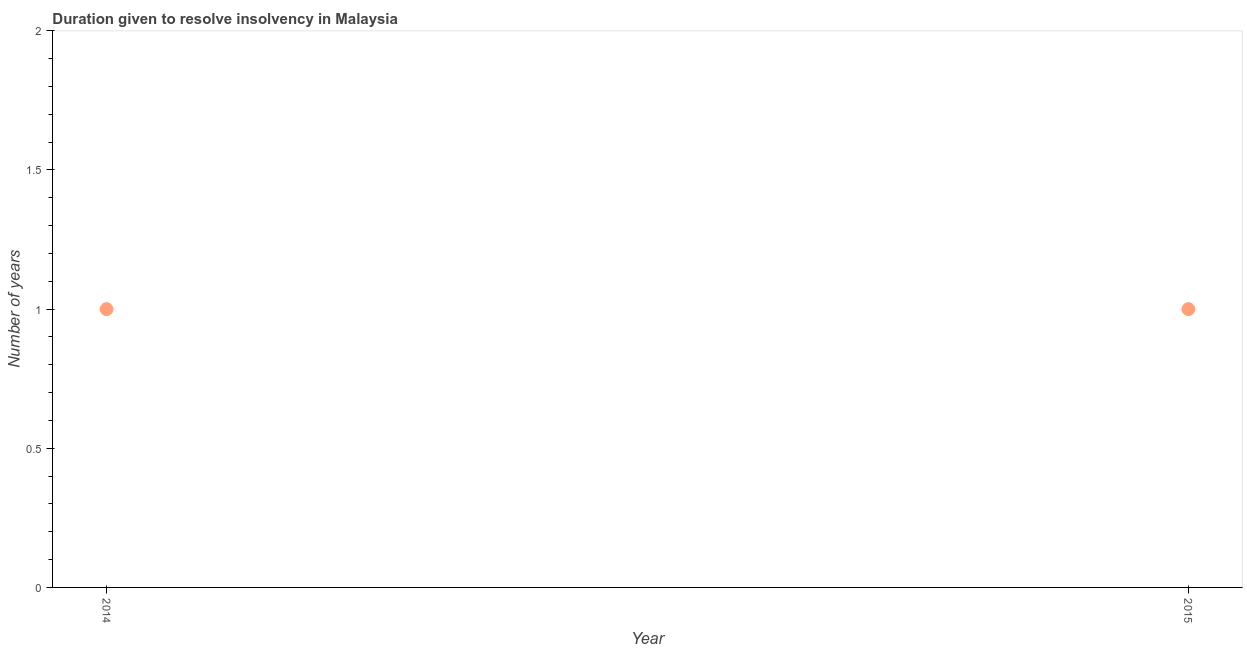What is the number of years to resolve insolvency in 2015?
Ensure brevity in your answer.  1. Across all years, what is the maximum number of years to resolve insolvency?
Give a very brief answer. 1. Across all years, what is the minimum number of years to resolve insolvency?
Your response must be concise. 1. What is the sum of the number of years to resolve insolvency?
Provide a succinct answer. 2. What is the difference between the number of years to resolve insolvency in 2014 and 2015?
Your response must be concise. 0. What is the average number of years to resolve insolvency per year?
Keep it short and to the point. 1. What is the median number of years to resolve insolvency?
Offer a terse response. 1. Do a majority of the years between 2015 and 2014 (inclusive) have number of years to resolve insolvency greater than 1.7 ?
Your answer should be compact. No. What is the ratio of the number of years to resolve insolvency in 2014 to that in 2015?
Your answer should be very brief. 1. Does the number of years to resolve insolvency monotonically increase over the years?
Ensure brevity in your answer.  No. Does the graph contain any zero values?
Provide a short and direct response. No. What is the title of the graph?
Offer a terse response. Duration given to resolve insolvency in Malaysia. What is the label or title of the X-axis?
Your answer should be very brief. Year. What is the label or title of the Y-axis?
Make the answer very short. Number of years. What is the Number of years in 2015?
Give a very brief answer. 1. What is the ratio of the Number of years in 2014 to that in 2015?
Give a very brief answer. 1. 